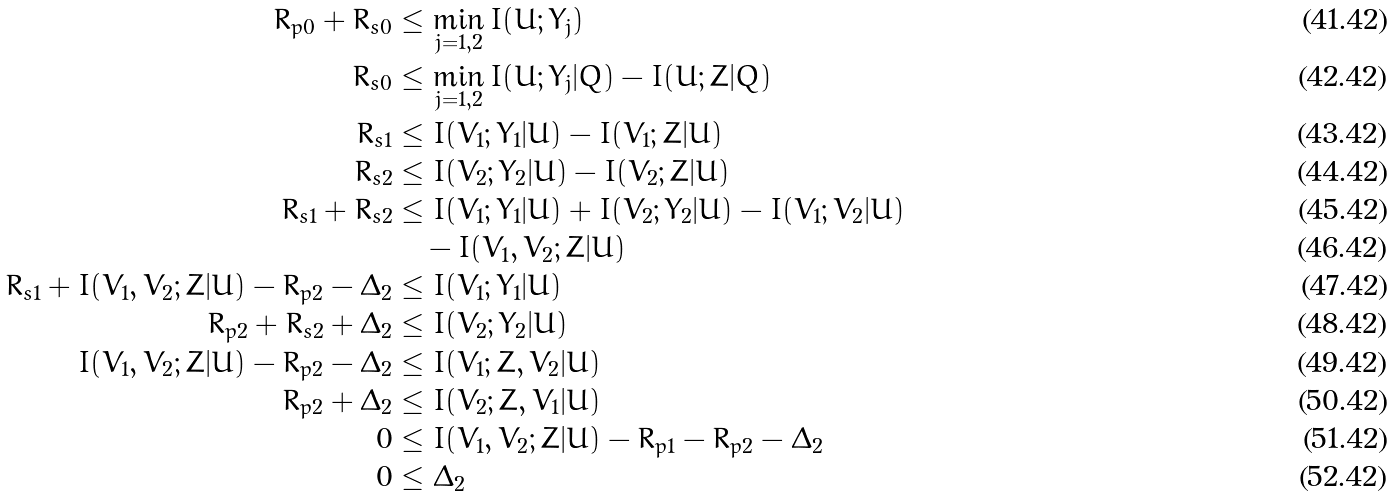<formula> <loc_0><loc_0><loc_500><loc_500>R _ { p 0 } + R _ { s 0 } & \leq \min _ { j = 1 , 2 } I ( U ; Y _ { j } ) \\ R _ { s 0 } & \leq \min _ { j = 1 , 2 } I ( U ; Y _ { j } | Q ) - I ( U ; Z | Q ) \\ R _ { s 1 } & \leq I ( V _ { 1 } ; Y _ { 1 } | U ) - I ( V _ { 1 } ; Z | U ) \\ R _ { s 2 } & \leq I ( V _ { 2 } ; Y _ { 2 } | U ) - I ( V _ { 2 } ; Z | U ) \\ R _ { s 1 } + R _ { s 2 } & \leq I ( V _ { 1 } ; Y _ { 1 } | U ) + I ( V _ { 2 } ; Y _ { 2 } | U ) - I ( V _ { 1 } ; V _ { 2 } | U ) \\ & \quad - I ( V _ { 1 } , V _ { 2 } ; Z | U ) \\ R _ { s 1 } + I ( V _ { 1 } , V _ { 2 } ; Z | U ) - R _ { p 2 } - \Delta _ { 2 } & \leq I ( V _ { 1 } ; Y _ { 1 } | U ) \\ R _ { p 2 } + R _ { s 2 } + \Delta _ { 2 } & \leq I ( V _ { 2 } ; Y _ { 2 } | U ) \\ I ( V _ { 1 } , V _ { 2 } ; Z | U ) - R _ { p 2 } - \Delta _ { 2 } & \leq I ( V _ { 1 } ; Z , V _ { 2 } | U ) \\ R _ { p 2 } + \Delta _ { 2 } & \leq I ( V _ { 2 } ; Z , V _ { 1 } | U ) \\ 0 & \leq I ( V _ { 1 } , V _ { 2 } ; Z | U ) - R _ { p 1 } - R _ { p 2 } - \Delta _ { 2 } \\ 0 & \leq \Delta _ { 2 }</formula> 